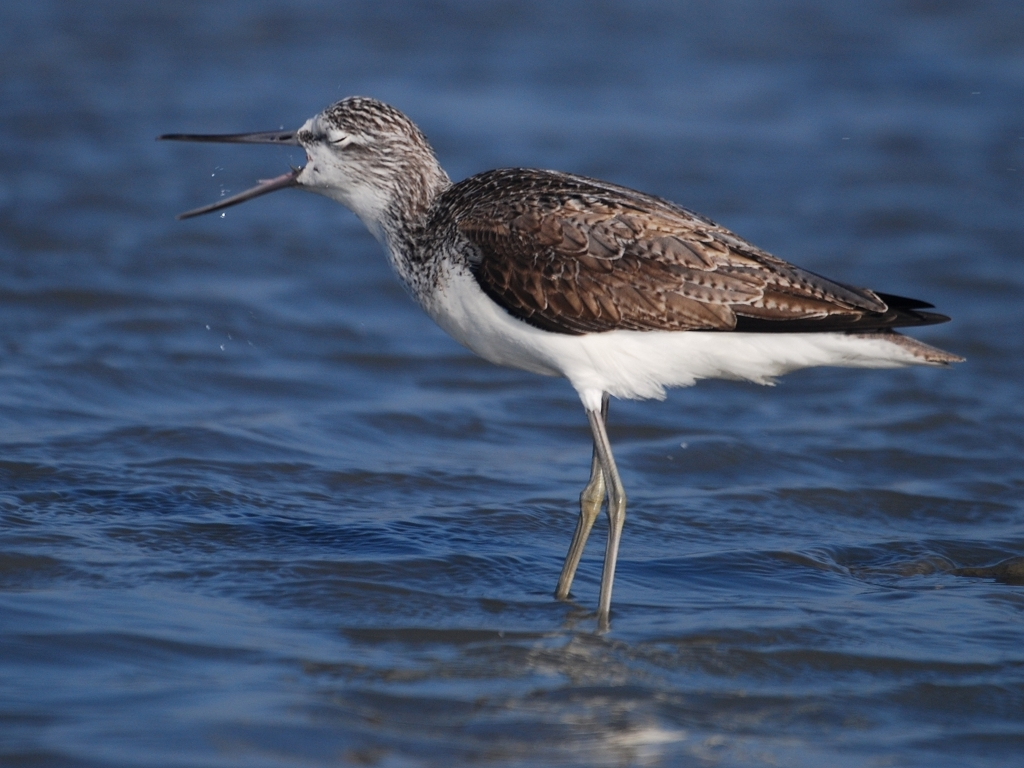Can you tell me about this bird's habitat? This species of bird typically inhabits coastal areas, where it can be found on beaches and mudflats searching for food such as small fish and crustaceans. What adaptations does it have for its habitat? Such birds have long legs for wading through shallow waters, and their long, pointed beaks are adapted to probe the sand and mud for prey. Their plumage also provides camouflage against the sandy and rocky shorelines. 